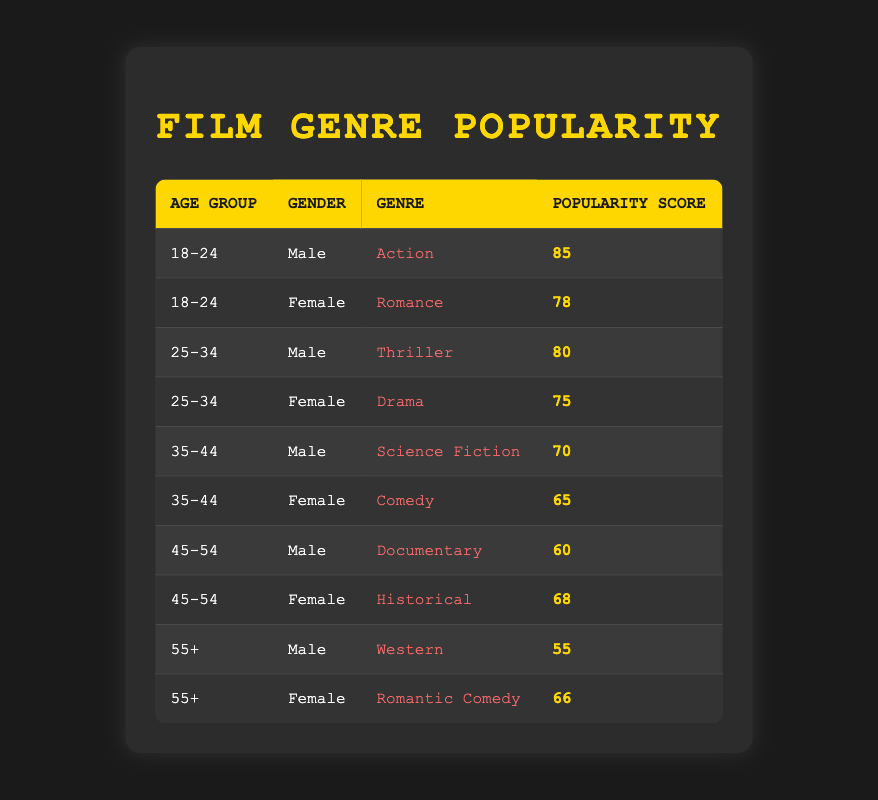What is the most popular film genre among 18-24-year-old males? The table shows that the most popular genre for the 18-24 age group and male gender is Action, with a popularity score of 85.
Answer: Action Which film genre has the highest score for females in the 25-34 age group? According to the table, the highest popularity score for females in the 25-34 age group is for Drama, with a score of 75.
Answer: Drama Is Comedy more popular than Thriller among females aged 35-44? The popularity score for Comedy among females aged 35-44 is 65, while Thriller is not present for females in this age group. Thus, it's not possible to make a direct comparison.
Answer: No What is the average popularity score for male film genres across all age groups? To calculate the average score for male genres, we sum the scores: 85 (Action) + 80 (Thriller) + 70 (Science Fiction) + 60 (Documentary) + 55 (Western) = 350. There are 5 data points, thus the average is 350 / 5 = 70.
Answer: 70 For the age group 55+, what is the difference in popularity score between males and females? The popularity score for males in the 55+ group is 55 (Western), and for females, it is 66 (Romantic Comedy). The difference is 66 - 55 = 11.
Answer: 11 Does any age group have a higher popularity for Romance than Thriller? Only the 18-24 age group has Romance as a genre for females at a score of 78, and Thriller appears in the 25-34 age group for males at a score of 80. Thus, no age group has higher popularity for Romance.
Answer: No What is the total popularity score for all genres in the 45-54 age group? The genres in the 45-54 age group are Documentary (60) and Historical (68). Summing these gives 60 + 68 = 128.
Answer: 128 Which film genre is least popular among males aged 55 and older? The table indicates the least popular genre for males aged 55 and older is Western, with a popularity score of 55.
Answer: Western 